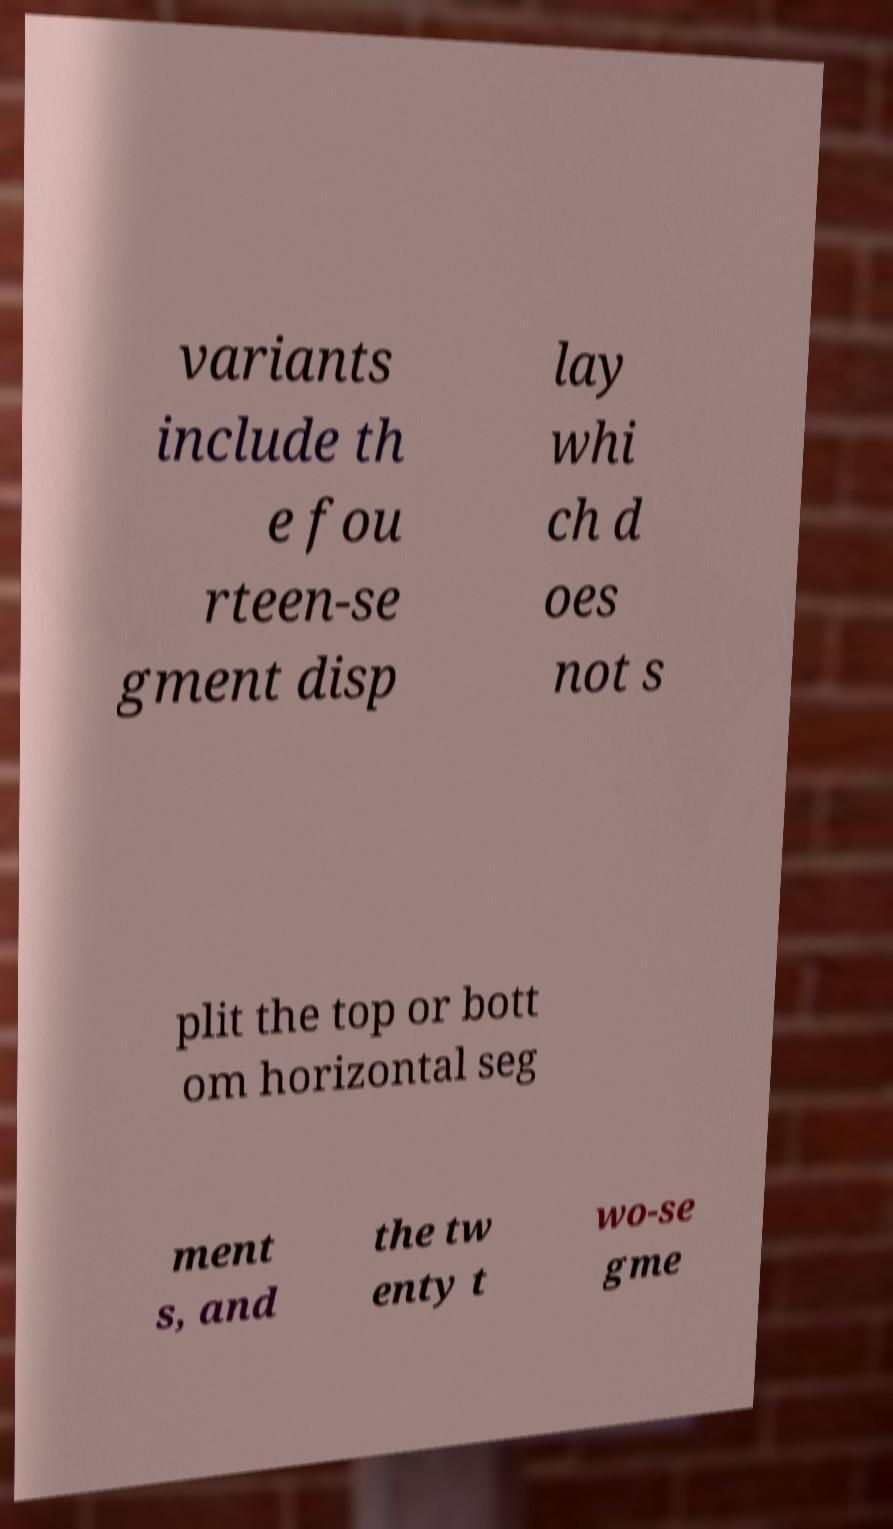Could you assist in decoding the text presented in this image and type it out clearly? variants include th e fou rteen-se gment disp lay whi ch d oes not s plit the top or bott om horizontal seg ment s, and the tw enty t wo-se gme 